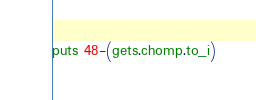Convert code to text. <code><loc_0><loc_0><loc_500><loc_500><_Ruby_>puts 48-(gets.chomp.to_i)</code> 